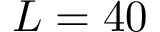<formula> <loc_0><loc_0><loc_500><loc_500>L = 4 0</formula> 